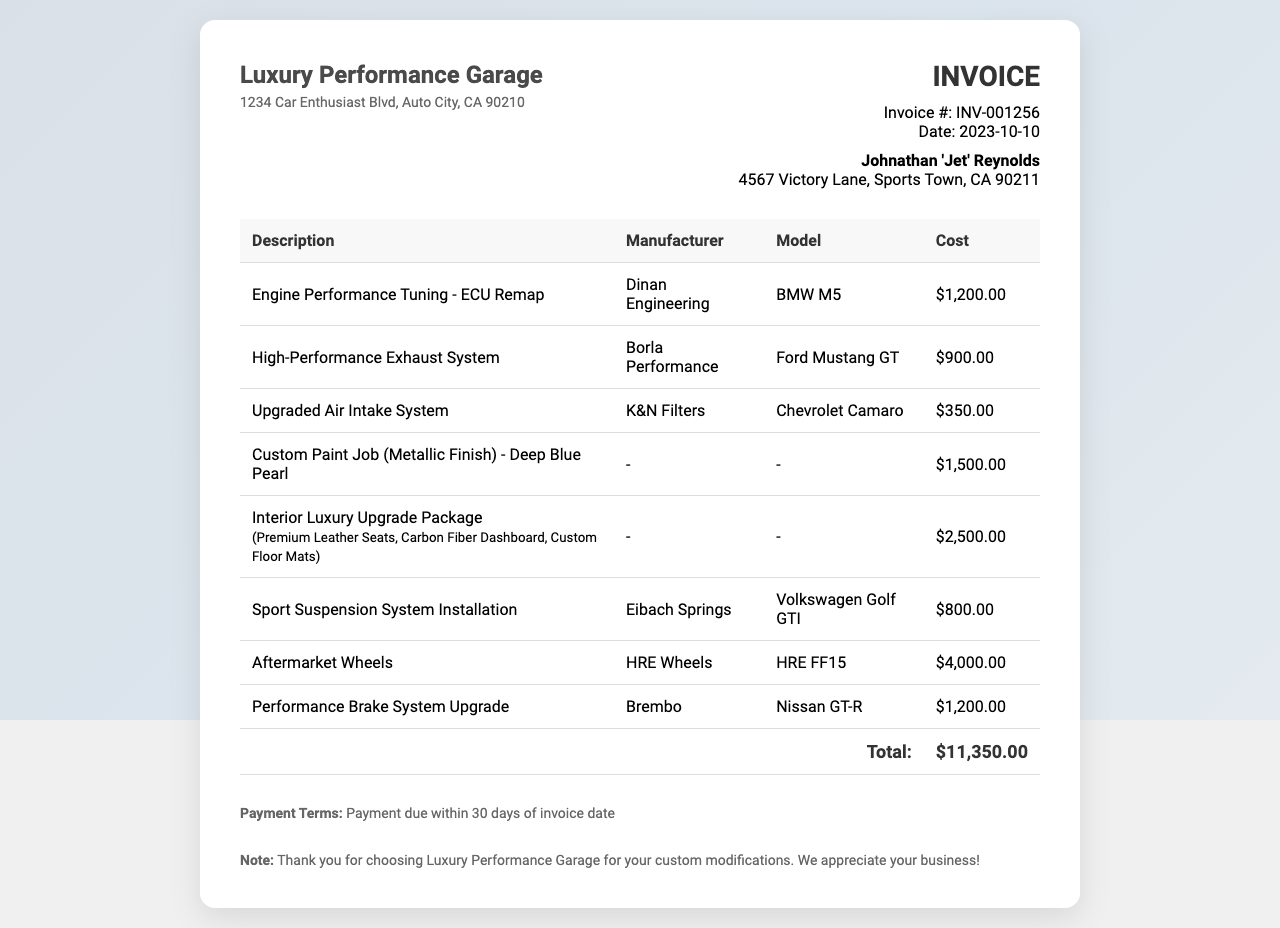What is the invoice number? The invoice number is a unique identifier for the invoice that helps in tracking. It is found near the top of the document.
Answer: INV-001256 What is the total cost for the custom modifications? The total cost is displayed at the bottom of the invoice, summarizing all the individual costs listed.
Answer: $11,350.00 What date was the invoice issued? The invoice date indicates when the billing was done and is found in the invoice information section.
Answer: 2023-10-10 Who is the customer? The customer information is provided in the invoice details, including their name and address.
Answer: Johnathan 'Jet' Reynolds How many performance upgrades are listed in the invoice? The total number of performance upgrades can be counted from the items listed in the table of costs.
Answer: 5 Which company provides the engine performance tuning? The manufacturer name for a specific service is usually listed next to the description of the service in the table.
Answer: Dinan Engineering What is the cost of the custom paint job? The cost for a specific aesthetic enhancement is found in the table under the relevant description.
Answer: $1,500.00 What is the payment term? The payment terms outline the conditions under which the payment is due, commonly found towards the end of the invoice.
Answer: Payment due within 30 days of invoice date What type of suspension system is mentioned? The suspension type is specified in the table of upgrades, indicating the nature of the installation.
Answer: Sport Suspension System Installation 